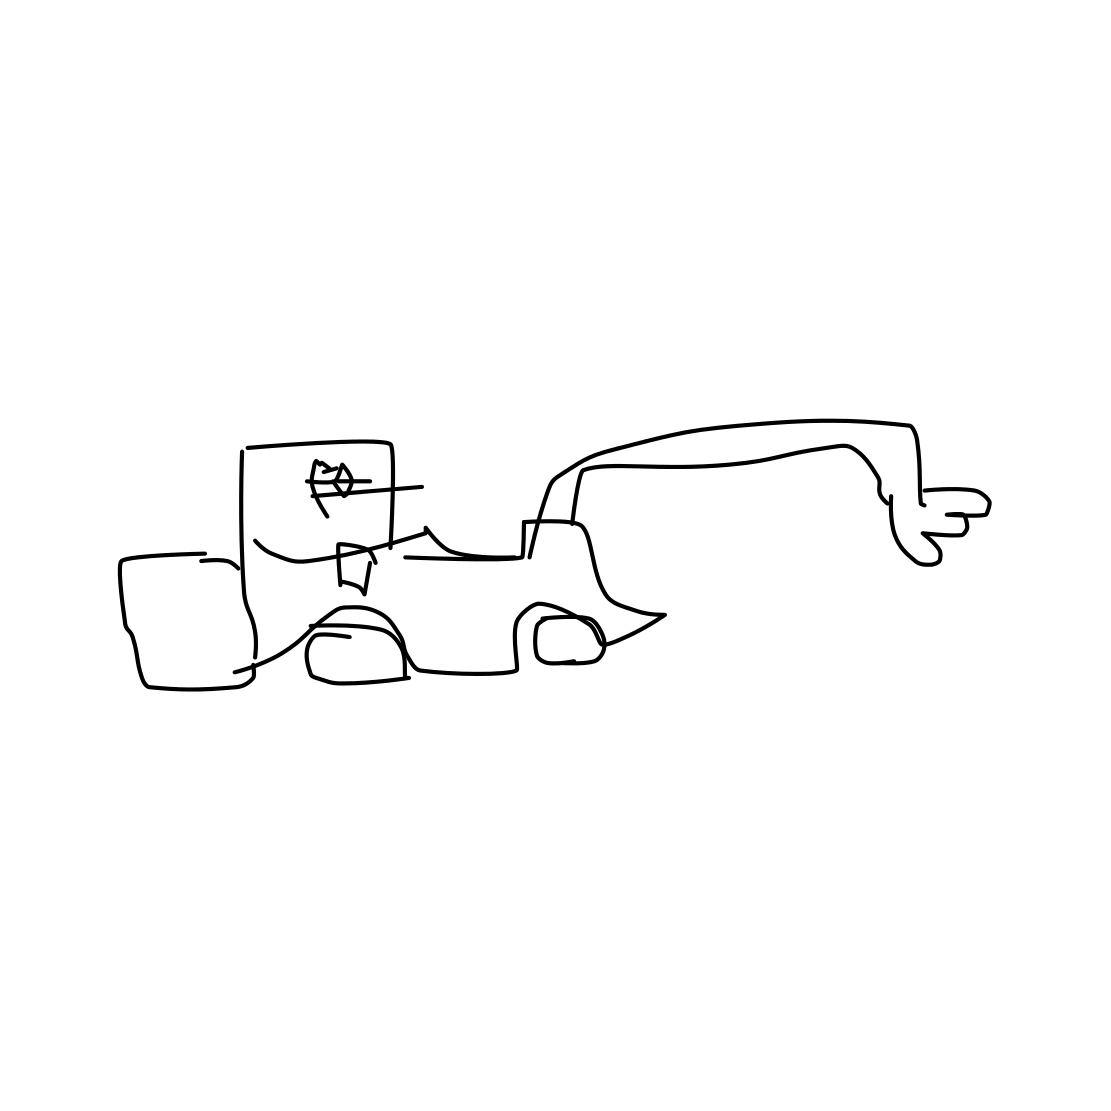Is this a canoe in the image? No 